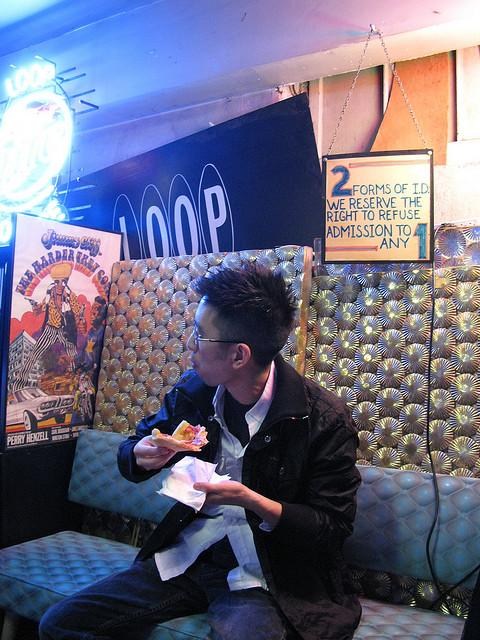Does the man have any pizza left?
Be succinct. Yes. Is the man with friends?
Be succinct. No. What do you call a meal in this setting?
Keep it brief. Casual. What two numbers are shown on this man's sign?
Write a very short answer. 2. Can you buy Kale here?
Be succinct. No. How many ID's are needed at this place?
Short answer required. 2. Is it a marketplace?
Concise answer only. No. 